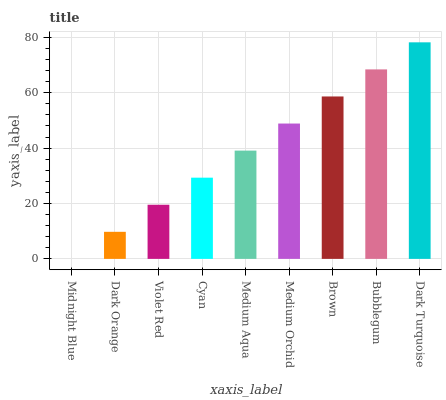Is Midnight Blue the minimum?
Answer yes or no. Yes. Is Dark Turquoise the maximum?
Answer yes or no. Yes. Is Dark Orange the minimum?
Answer yes or no. No. Is Dark Orange the maximum?
Answer yes or no. No. Is Dark Orange greater than Midnight Blue?
Answer yes or no. Yes. Is Midnight Blue less than Dark Orange?
Answer yes or no. Yes. Is Midnight Blue greater than Dark Orange?
Answer yes or no. No. Is Dark Orange less than Midnight Blue?
Answer yes or no. No. Is Medium Aqua the high median?
Answer yes or no. Yes. Is Medium Aqua the low median?
Answer yes or no. Yes. Is Cyan the high median?
Answer yes or no. No. Is Brown the low median?
Answer yes or no. No. 